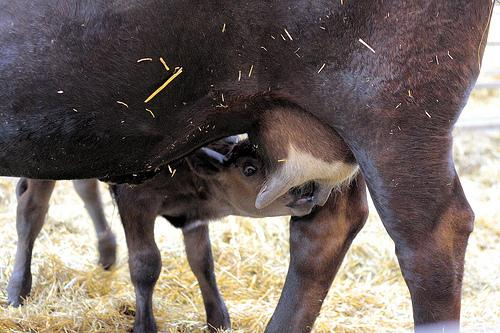Mention the key features and objects of the image in a concise manner. Calf nursing from mother, various body parts of both animals, pieces of straw, hay, and steel fence. In a few words, describe the interactions between the calf and its mother. Baby calf nursing from its mother, with its face close to the mother's teats and body nearby. Provide a short description of the calf's mother. The mother cow has a brown body with a brown and tan udder covered in hair, prominent big eye, and an ear visible. Provide a brief description of the primary animals in the image. A baby calf and its mother, both brown, with the calf nursing and looking up while straw and hay are scattered around them. Describe the notable objects and actions in relation to the baby calf. Baby calf has deep black eyes, is nursing from brown and white udders, and has a dark brown belly, with visible teeth, and surprised expression. Write a brief summary about the overall scene and caption. A baby calf nursing from its mother among hay and straw, with their body parts, expressions, and surroundings captured in detail. Touch upon the photographic aspects and achievements of the image. The photo, taken by Jackson Mingus, has won an award for its details and appeared in National Geographic and a farming magazine. Explain the calf's position and facial features. The calf positioned below its mom, has deep black eyes, a dark nose, a lightly open mouth, and a surprised expression. Briefly describe the visual aspects focusing on the colors and textures. A mix of dark and light browns in fur and udders, grays in teats, yellow hay, and steel fence, with various textures such as hair and straw. Mention the setting and props in the image. The setting includes a steel fence, yellow hay, and straw on the ground, with pieces of straw scattered on the cow's fur. 